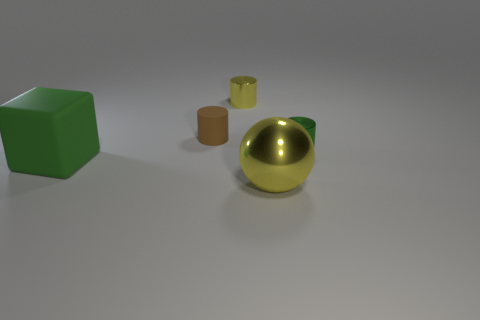Is there any other thing that is the same shape as the green rubber thing?
Offer a terse response. No. Is there a metal thing that is on the left side of the tiny green metal cylinder to the right of the big green rubber thing?
Provide a succinct answer. Yes. Are there fewer tiny things that are on the right side of the small yellow shiny cylinder than small objects that are to the right of the tiny matte object?
Give a very brief answer. Yes. There is a shiny object that is in front of the object left of the matte object behind the tiny green metal cylinder; what size is it?
Ensure brevity in your answer.  Large. Is the size of the shiny object that is behind the green metallic thing the same as the tiny rubber cylinder?
Provide a short and direct response. Yes. How many other objects are there of the same material as the tiny brown thing?
Your answer should be very brief. 1. Are there more big green matte blocks than small red balls?
Give a very brief answer. Yes. There is a yellow thing behind the cylinder that is on the right side of the yellow metallic object that is behind the small brown matte cylinder; what is it made of?
Your response must be concise. Metal. Are there any rubber objects of the same color as the rubber cube?
Your answer should be very brief. No. The brown matte object that is the same size as the yellow metallic cylinder is what shape?
Offer a very short reply. Cylinder. 